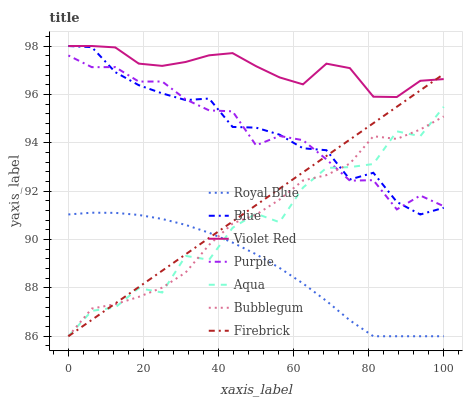Does Royal Blue have the minimum area under the curve?
Answer yes or no. Yes. Does Violet Red have the maximum area under the curve?
Answer yes or no. Yes. Does Purple have the minimum area under the curve?
Answer yes or no. No. Does Purple have the maximum area under the curve?
Answer yes or no. No. Is Firebrick the smoothest?
Answer yes or no. Yes. Is Aqua the roughest?
Answer yes or no. Yes. Is Violet Red the smoothest?
Answer yes or no. No. Is Violet Red the roughest?
Answer yes or no. No. Does Firebrick have the lowest value?
Answer yes or no. Yes. Does Purple have the lowest value?
Answer yes or no. No. Does Violet Red have the highest value?
Answer yes or no. Yes. Does Purple have the highest value?
Answer yes or no. No. Is Bubblegum less than Violet Red?
Answer yes or no. Yes. Is Violet Red greater than Aqua?
Answer yes or no. Yes. Does Purple intersect Firebrick?
Answer yes or no. Yes. Is Purple less than Firebrick?
Answer yes or no. No. Is Purple greater than Firebrick?
Answer yes or no. No. Does Bubblegum intersect Violet Red?
Answer yes or no. No. 